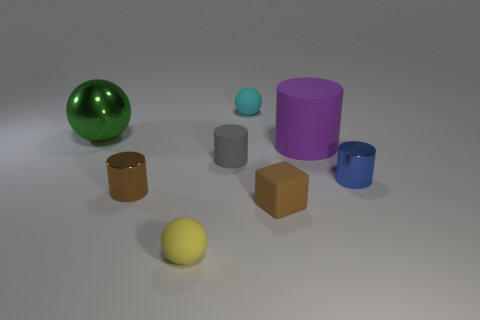How many other tiny brown cubes have the same material as the tiny brown block?
Offer a very short reply. 0. There is a small matte object that is to the right of the tiny sphere behind the brown rubber block; are there any small brown metallic cylinders that are on the right side of it?
Your answer should be very brief. No. There is a brown thing that is the same material as the gray cylinder; what shape is it?
Your answer should be very brief. Cube. Is the number of yellow matte balls greater than the number of large yellow rubber cylinders?
Give a very brief answer. Yes. Does the small gray matte object have the same shape as the big thing that is right of the cyan rubber sphere?
Keep it short and to the point. Yes. What is the material of the brown cylinder?
Offer a terse response. Metal. The tiny metal object on the right side of the small shiny thing that is in front of the shiny object right of the small gray cylinder is what color?
Provide a short and direct response. Blue. There is a tiny cyan thing that is the same shape as the large green object; what is its material?
Your answer should be compact. Rubber. What number of green balls are the same size as the brown cylinder?
Keep it short and to the point. 0. How many purple rubber things are there?
Give a very brief answer. 1. 